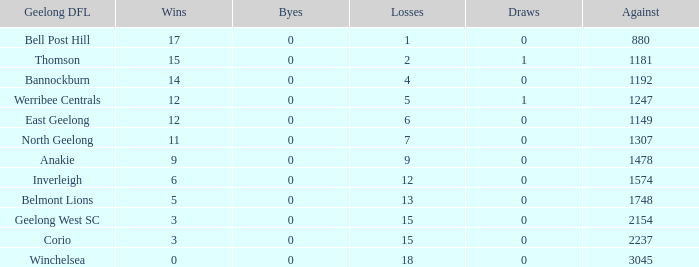What is the complete sum of losses when byes were above 0? 0.0. 